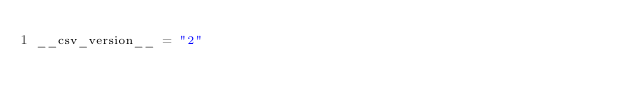Convert code to text. <code><loc_0><loc_0><loc_500><loc_500><_Python_>__csv_version__ = "2"
</code> 